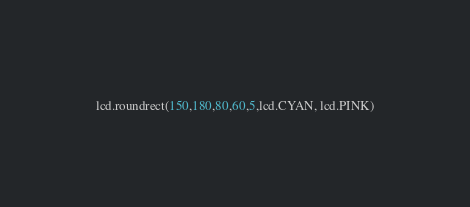Convert code to text. <code><loc_0><loc_0><loc_500><loc_500><_Python_>lcd.roundrect(150,180,80,60,5,lcd.CYAN, lcd.PINK)
</code> 